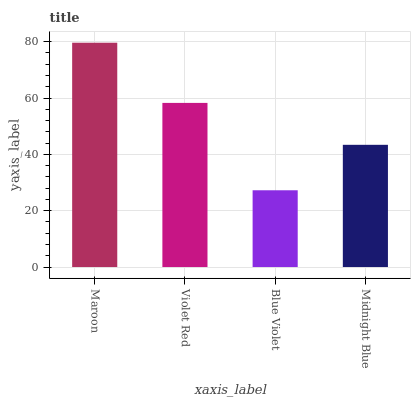Is Blue Violet the minimum?
Answer yes or no. Yes. Is Maroon the maximum?
Answer yes or no. Yes. Is Violet Red the minimum?
Answer yes or no. No. Is Violet Red the maximum?
Answer yes or no. No. Is Maroon greater than Violet Red?
Answer yes or no. Yes. Is Violet Red less than Maroon?
Answer yes or no. Yes. Is Violet Red greater than Maroon?
Answer yes or no. No. Is Maroon less than Violet Red?
Answer yes or no. No. Is Violet Red the high median?
Answer yes or no. Yes. Is Midnight Blue the low median?
Answer yes or no. Yes. Is Maroon the high median?
Answer yes or no. No. Is Maroon the low median?
Answer yes or no. No. 